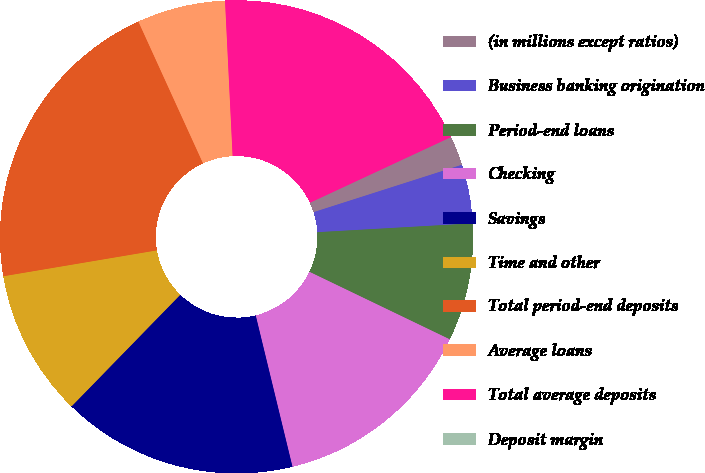Convert chart to OTSL. <chart><loc_0><loc_0><loc_500><loc_500><pie_chart><fcel>(in millions except ratios)<fcel>Business banking origination<fcel>Period-end loans<fcel>Checking<fcel>Savings<fcel>Time and other<fcel>Total period-end deposits<fcel>Average loans<fcel>Total average deposits<fcel>Deposit margin<nl><fcel>2.01%<fcel>4.02%<fcel>8.04%<fcel>14.07%<fcel>16.08%<fcel>10.05%<fcel>20.85%<fcel>6.03%<fcel>18.84%<fcel>0.0%<nl></chart> 